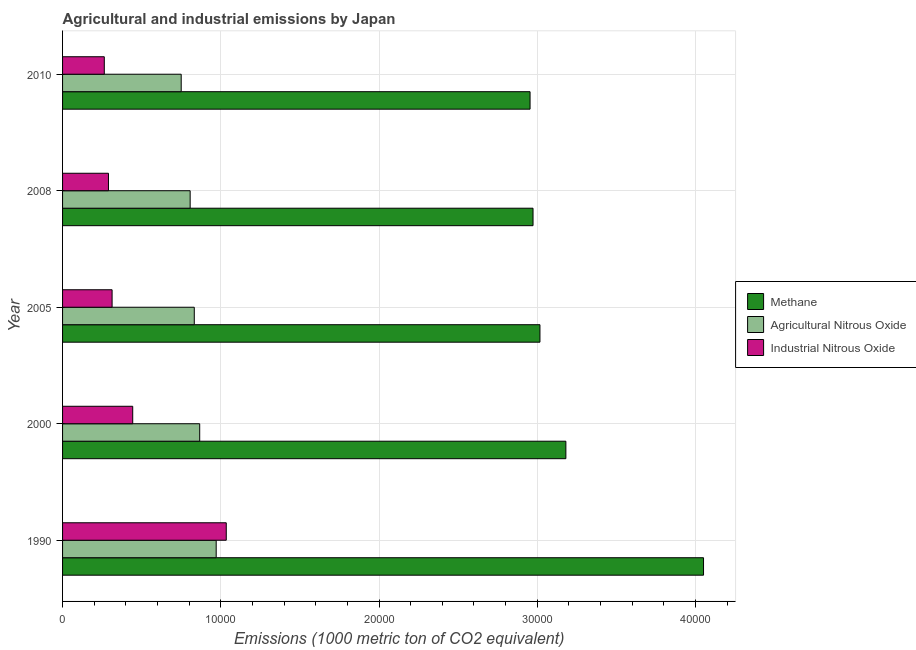Are the number of bars per tick equal to the number of legend labels?
Provide a succinct answer. Yes. How many bars are there on the 2nd tick from the top?
Ensure brevity in your answer.  3. What is the label of the 3rd group of bars from the top?
Your answer should be compact. 2005. What is the amount of industrial nitrous oxide emissions in 2008?
Keep it short and to the point. 2901. Across all years, what is the maximum amount of agricultural nitrous oxide emissions?
Offer a terse response. 9708.8. Across all years, what is the minimum amount of agricultural nitrous oxide emissions?
Provide a succinct answer. 7497.9. In which year was the amount of agricultural nitrous oxide emissions maximum?
Keep it short and to the point. 1990. In which year was the amount of agricultural nitrous oxide emissions minimum?
Offer a very short reply. 2010. What is the total amount of agricultural nitrous oxide emissions in the graph?
Provide a succinct answer. 4.23e+04. What is the difference between the amount of industrial nitrous oxide emissions in 1990 and that in 2010?
Offer a terse response. 7707.7. What is the difference between the amount of methane emissions in 1990 and the amount of agricultural nitrous oxide emissions in 2010?
Ensure brevity in your answer.  3.30e+04. What is the average amount of agricultural nitrous oxide emissions per year?
Make the answer very short. 8452.46. In the year 2000, what is the difference between the amount of methane emissions and amount of agricultural nitrous oxide emissions?
Offer a terse response. 2.31e+04. What is the ratio of the amount of methane emissions in 1990 to that in 2000?
Provide a short and direct response. 1.27. What is the difference between the highest and the second highest amount of agricultural nitrous oxide emissions?
Offer a terse response. 1041.6. What is the difference between the highest and the lowest amount of methane emissions?
Your answer should be compact. 1.10e+04. In how many years, is the amount of methane emissions greater than the average amount of methane emissions taken over all years?
Your answer should be very brief. 1. What does the 3rd bar from the top in 2005 represents?
Your response must be concise. Methane. What does the 1st bar from the bottom in 2000 represents?
Give a very brief answer. Methane. Are all the bars in the graph horizontal?
Make the answer very short. Yes. How many years are there in the graph?
Provide a succinct answer. 5. Are the values on the major ticks of X-axis written in scientific E-notation?
Give a very brief answer. No. Does the graph contain grids?
Provide a short and direct response. Yes. How many legend labels are there?
Give a very brief answer. 3. How are the legend labels stacked?
Offer a very short reply. Vertical. What is the title of the graph?
Ensure brevity in your answer.  Agricultural and industrial emissions by Japan. What is the label or title of the X-axis?
Provide a succinct answer. Emissions (1000 metric ton of CO2 equivalent). What is the Emissions (1000 metric ton of CO2 equivalent) in Methane in 1990?
Keep it short and to the point. 4.05e+04. What is the Emissions (1000 metric ton of CO2 equivalent) of Agricultural Nitrous Oxide in 1990?
Make the answer very short. 9708.8. What is the Emissions (1000 metric ton of CO2 equivalent) in Industrial Nitrous Oxide in 1990?
Your response must be concise. 1.03e+04. What is the Emissions (1000 metric ton of CO2 equivalent) of Methane in 2000?
Provide a succinct answer. 3.18e+04. What is the Emissions (1000 metric ton of CO2 equivalent) in Agricultural Nitrous Oxide in 2000?
Offer a terse response. 8667.2. What is the Emissions (1000 metric ton of CO2 equivalent) of Industrial Nitrous Oxide in 2000?
Your answer should be compact. 4433.9. What is the Emissions (1000 metric ton of CO2 equivalent) in Methane in 2005?
Keep it short and to the point. 3.02e+04. What is the Emissions (1000 metric ton of CO2 equivalent) of Agricultural Nitrous Oxide in 2005?
Make the answer very short. 8324.7. What is the Emissions (1000 metric ton of CO2 equivalent) in Industrial Nitrous Oxide in 2005?
Ensure brevity in your answer.  3130.3. What is the Emissions (1000 metric ton of CO2 equivalent) in Methane in 2008?
Your answer should be compact. 2.97e+04. What is the Emissions (1000 metric ton of CO2 equivalent) of Agricultural Nitrous Oxide in 2008?
Your answer should be very brief. 8063.7. What is the Emissions (1000 metric ton of CO2 equivalent) in Industrial Nitrous Oxide in 2008?
Your response must be concise. 2901. What is the Emissions (1000 metric ton of CO2 equivalent) in Methane in 2010?
Your answer should be very brief. 2.95e+04. What is the Emissions (1000 metric ton of CO2 equivalent) of Agricultural Nitrous Oxide in 2010?
Make the answer very short. 7497.9. What is the Emissions (1000 metric ton of CO2 equivalent) of Industrial Nitrous Oxide in 2010?
Provide a short and direct response. 2637.7. Across all years, what is the maximum Emissions (1000 metric ton of CO2 equivalent) in Methane?
Ensure brevity in your answer.  4.05e+04. Across all years, what is the maximum Emissions (1000 metric ton of CO2 equivalent) of Agricultural Nitrous Oxide?
Your answer should be very brief. 9708.8. Across all years, what is the maximum Emissions (1000 metric ton of CO2 equivalent) in Industrial Nitrous Oxide?
Provide a succinct answer. 1.03e+04. Across all years, what is the minimum Emissions (1000 metric ton of CO2 equivalent) of Methane?
Your answer should be compact. 2.95e+04. Across all years, what is the minimum Emissions (1000 metric ton of CO2 equivalent) in Agricultural Nitrous Oxide?
Offer a terse response. 7497.9. Across all years, what is the minimum Emissions (1000 metric ton of CO2 equivalent) of Industrial Nitrous Oxide?
Provide a succinct answer. 2637.7. What is the total Emissions (1000 metric ton of CO2 equivalent) of Methane in the graph?
Your response must be concise. 1.62e+05. What is the total Emissions (1000 metric ton of CO2 equivalent) in Agricultural Nitrous Oxide in the graph?
Offer a terse response. 4.23e+04. What is the total Emissions (1000 metric ton of CO2 equivalent) of Industrial Nitrous Oxide in the graph?
Keep it short and to the point. 2.34e+04. What is the difference between the Emissions (1000 metric ton of CO2 equivalent) in Methane in 1990 and that in 2000?
Your response must be concise. 8700.7. What is the difference between the Emissions (1000 metric ton of CO2 equivalent) in Agricultural Nitrous Oxide in 1990 and that in 2000?
Provide a succinct answer. 1041.6. What is the difference between the Emissions (1000 metric ton of CO2 equivalent) of Industrial Nitrous Oxide in 1990 and that in 2000?
Your response must be concise. 5911.5. What is the difference between the Emissions (1000 metric ton of CO2 equivalent) of Methane in 1990 and that in 2005?
Give a very brief answer. 1.03e+04. What is the difference between the Emissions (1000 metric ton of CO2 equivalent) of Agricultural Nitrous Oxide in 1990 and that in 2005?
Make the answer very short. 1384.1. What is the difference between the Emissions (1000 metric ton of CO2 equivalent) of Industrial Nitrous Oxide in 1990 and that in 2005?
Your answer should be compact. 7215.1. What is the difference between the Emissions (1000 metric ton of CO2 equivalent) in Methane in 1990 and that in 2008?
Ensure brevity in your answer.  1.08e+04. What is the difference between the Emissions (1000 metric ton of CO2 equivalent) of Agricultural Nitrous Oxide in 1990 and that in 2008?
Your answer should be very brief. 1645.1. What is the difference between the Emissions (1000 metric ton of CO2 equivalent) in Industrial Nitrous Oxide in 1990 and that in 2008?
Ensure brevity in your answer.  7444.4. What is the difference between the Emissions (1000 metric ton of CO2 equivalent) in Methane in 1990 and that in 2010?
Provide a succinct answer. 1.10e+04. What is the difference between the Emissions (1000 metric ton of CO2 equivalent) of Agricultural Nitrous Oxide in 1990 and that in 2010?
Your response must be concise. 2210.9. What is the difference between the Emissions (1000 metric ton of CO2 equivalent) of Industrial Nitrous Oxide in 1990 and that in 2010?
Keep it short and to the point. 7707.7. What is the difference between the Emissions (1000 metric ton of CO2 equivalent) in Methane in 2000 and that in 2005?
Give a very brief answer. 1638. What is the difference between the Emissions (1000 metric ton of CO2 equivalent) in Agricultural Nitrous Oxide in 2000 and that in 2005?
Keep it short and to the point. 342.5. What is the difference between the Emissions (1000 metric ton of CO2 equivalent) of Industrial Nitrous Oxide in 2000 and that in 2005?
Keep it short and to the point. 1303.6. What is the difference between the Emissions (1000 metric ton of CO2 equivalent) in Methane in 2000 and that in 2008?
Keep it short and to the point. 2075.3. What is the difference between the Emissions (1000 metric ton of CO2 equivalent) of Agricultural Nitrous Oxide in 2000 and that in 2008?
Ensure brevity in your answer.  603.5. What is the difference between the Emissions (1000 metric ton of CO2 equivalent) in Industrial Nitrous Oxide in 2000 and that in 2008?
Provide a succinct answer. 1532.9. What is the difference between the Emissions (1000 metric ton of CO2 equivalent) in Methane in 2000 and that in 2010?
Provide a succinct answer. 2263.3. What is the difference between the Emissions (1000 metric ton of CO2 equivalent) in Agricultural Nitrous Oxide in 2000 and that in 2010?
Keep it short and to the point. 1169.3. What is the difference between the Emissions (1000 metric ton of CO2 equivalent) in Industrial Nitrous Oxide in 2000 and that in 2010?
Offer a terse response. 1796.2. What is the difference between the Emissions (1000 metric ton of CO2 equivalent) in Methane in 2005 and that in 2008?
Offer a terse response. 437.3. What is the difference between the Emissions (1000 metric ton of CO2 equivalent) of Agricultural Nitrous Oxide in 2005 and that in 2008?
Ensure brevity in your answer.  261. What is the difference between the Emissions (1000 metric ton of CO2 equivalent) of Industrial Nitrous Oxide in 2005 and that in 2008?
Provide a short and direct response. 229.3. What is the difference between the Emissions (1000 metric ton of CO2 equivalent) in Methane in 2005 and that in 2010?
Provide a succinct answer. 625.3. What is the difference between the Emissions (1000 metric ton of CO2 equivalent) of Agricultural Nitrous Oxide in 2005 and that in 2010?
Keep it short and to the point. 826.8. What is the difference between the Emissions (1000 metric ton of CO2 equivalent) in Industrial Nitrous Oxide in 2005 and that in 2010?
Ensure brevity in your answer.  492.6. What is the difference between the Emissions (1000 metric ton of CO2 equivalent) in Methane in 2008 and that in 2010?
Your response must be concise. 188. What is the difference between the Emissions (1000 metric ton of CO2 equivalent) in Agricultural Nitrous Oxide in 2008 and that in 2010?
Make the answer very short. 565.8. What is the difference between the Emissions (1000 metric ton of CO2 equivalent) of Industrial Nitrous Oxide in 2008 and that in 2010?
Your answer should be compact. 263.3. What is the difference between the Emissions (1000 metric ton of CO2 equivalent) in Methane in 1990 and the Emissions (1000 metric ton of CO2 equivalent) in Agricultural Nitrous Oxide in 2000?
Your answer should be compact. 3.18e+04. What is the difference between the Emissions (1000 metric ton of CO2 equivalent) of Methane in 1990 and the Emissions (1000 metric ton of CO2 equivalent) of Industrial Nitrous Oxide in 2000?
Keep it short and to the point. 3.61e+04. What is the difference between the Emissions (1000 metric ton of CO2 equivalent) of Agricultural Nitrous Oxide in 1990 and the Emissions (1000 metric ton of CO2 equivalent) of Industrial Nitrous Oxide in 2000?
Keep it short and to the point. 5274.9. What is the difference between the Emissions (1000 metric ton of CO2 equivalent) in Methane in 1990 and the Emissions (1000 metric ton of CO2 equivalent) in Agricultural Nitrous Oxide in 2005?
Provide a succinct answer. 3.22e+04. What is the difference between the Emissions (1000 metric ton of CO2 equivalent) of Methane in 1990 and the Emissions (1000 metric ton of CO2 equivalent) of Industrial Nitrous Oxide in 2005?
Keep it short and to the point. 3.74e+04. What is the difference between the Emissions (1000 metric ton of CO2 equivalent) in Agricultural Nitrous Oxide in 1990 and the Emissions (1000 metric ton of CO2 equivalent) in Industrial Nitrous Oxide in 2005?
Make the answer very short. 6578.5. What is the difference between the Emissions (1000 metric ton of CO2 equivalent) in Methane in 1990 and the Emissions (1000 metric ton of CO2 equivalent) in Agricultural Nitrous Oxide in 2008?
Offer a terse response. 3.24e+04. What is the difference between the Emissions (1000 metric ton of CO2 equivalent) of Methane in 1990 and the Emissions (1000 metric ton of CO2 equivalent) of Industrial Nitrous Oxide in 2008?
Give a very brief answer. 3.76e+04. What is the difference between the Emissions (1000 metric ton of CO2 equivalent) in Agricultural Nitrous Oxide in 1990 and the Emissions (1000 metric ton of CO2 equivalent) in Industrial Nitrous Oxide in 2008?
Ensure brevity in your answer.  6807.8. What is the difference between the Emissions (1000 metric ton of CO2 equivalent) in Methane in 1990 and the Emissions (1000 metric ton of CO2 equivalent) in Agricultural Nitrous Oxide in 2010?
Your answer should be compact. 3.30e+04. What is the difference between the Emissions (1000 metric ton of CO2 equivalent) in Methane in 1990 and the Emissions (1000 metric ton of CO2 equivalent) in Industrial Nitrous Oxide in 2010?
Keep it short and to the point. 3.79e+04. What is the difference between the Emissions (1000 metric ton of CO2 equivalent) in Agricultural Nitrous Oxide in 1990 and the Emissions (1000 metric ton of CO2 equivalent) in Industrial Nitrous Oxide in 2010?
Provide a short and direct response. 7071.1. What is the difference between the Emissions (1000 metric ton of CO2 equivalent) of Methane in 2000 and the Emissions (1000 metric ton of CO2 equivalent) of Agricultural Nitrous Oxide in 2005?
Provide a short and direct response. 2.35e+04. What is the difference between the Emissions (1000 metric ton of CO2 equivalent) of Methane in 2000 and the Emissions (1000 metric ton of CO2 equivalent) of Industrial Nitrous Oxide in 2005?
Make the answer very short. 2.87e+04. What is the difference between the Emissions (1000 metric ton of CO2 equivalent) of Agricultural Nitrous Oxide in 2000 and the Emissions (1000 metric ton of CO2 equivalent) of Industrial Nitrous Oxide in 2005?
Make the answer very short. 5536.9. What is the difference between the Emissions (1000 metric ton of CO2 equivalent) in Methane in 2000 and the Emissions (1000 metric ton of CO2 equivalent) in Agricultural Nitrous Oxide in 2008?
Your answer should be compact. 2.37e+04. What is the difference between the Emissions (1000 metric ton of CO2 equivalent) in Methane in 2000 and the Emissions (1000 metric ton of CO2 equivalent) in Industrial Nitrous Oxide in 2008?
Offer a terse response. 2.89e+04. What is the difference between the Emissions (1000 metric ton of CO2 equivalent) in Agricultural Nitrous Oxide in 2000 and the Emissions (1000 metric ton of CO2 equivalent) in Industrial Nitrous Oxide in 2008?
Keep it short and to the point. 5766.2. What is the difference between the Emissions (1000 metric ton of CO2 equivalent) of Methane in 2000 and the Emissions (1000 metric ton of CO2 equivalent) of Agricultural Nitrous Oxide in 2010?
Your response must be concise. 2.43e+04. What is the difference between the Emissions (1000 metric ton of CO2 equivalent) of Methane in 2000 and the Emissions (1000 metric ton of CO2 equivalent) of Industrial Nitrous Oxide in 2010?
Give a very brief answer. 2.92e+04. What is the difference between the Emissions (1000 metric ton of CO2 equivalent) of Agricultural Nitrous Oxide in 2000 and the Emissions (1000 metric ton of CO2 equivalent) of Industrial Nitrous Oxide in 2010?
Offer a very short reply. 6029.5. What is the difference between the Emissions (1000 metric ton of CO2 equivalent) in Methane in 2005 and the Emissions (1000 metric ton of CO2 equivalent) in Agricultural Nitrous Oxide in 2008?
Provide a short and direct response. 2.21e+04. What is the difference between the Emissions (1000 metric ton of CO2 equivalent) in Methane in 2005 and the Emissions (1000 metric ton of CO2 equivalent) in Industrial Nitrous Oxide in 2008?
Your answer should be very brief. 2.73e+04. What is the difference between the Emissions (1000 metric ton of CO2 equivalent) of Agricultural Nitrous Oxide in 2005 and the Emissions (1000 metric ton of CO2 equivalent) of Industrial Nitrous Oxide in 2008?
Keep it short and to the point. 5423.7. What is the difference between the Emissions (1000 metric ton of CO2 equivalent) in Methane in 2005 and the Emissions (1000 metric ton of CO2 equivalent) in Agricultural Nitrous Oxide in 2010?
Give a very brief answer. 2.27e+04. What is the difference between the Emissions (1000 metric ton of CO2 equivalent) in Methane in 2005 and the Emissions (1000 metric ton of CO2 equivalent) in Industrial Nitrous Oxide in 2010?
Make the answer very short. 2.75e+04. What is the difference between the Emissions (1000 metric ton of CO2 equivalent) of Agricultural Nitrous Oxide in 2005 and the Emissions (1000 metric ton of CO2 equivalent) of Industrial Nitrous Oxide in 2010?
Give a very brief answer. 5687. What is the difference between the Emissions (1000 metric ton of CO2 equivalent) of Methane in 2008 and the Emissions (1000 metric ton of CO2 equivalent) of Agricultural Nitrous Oxide in 2010?
Make the answer very short. 2.22e+04. What is the difference between the Emissions (1000 metric ton of CO2 equivalent) in Methane in 2008 and the Emissions (1000 metric ton of CO2 equivalent) in Industrial Nitrous Oxide in 2010?
Your answer should be very brief. 2.71e+04. What is the difference between the Emissions (1000 metric ton of CO2 equivalent) of Agricultural Nitrous Oxide in 2008 and the Emissions (1000 metric ton of CO2 equivalent) of Industrial Nitrous Oxide in 2010?
Offer a very short reply. 5426. What is the average Emissions (1000 metric ton of CO2 equivalent) in Methane per year?
Your answer should be very brief. 3.24e+04. What is the average Emissions (1000 metric ton of CO2 equivalent) of Agricultural Nitrous Oxide per year?
Ensure brevity in your answer.  8452.46. What is the average Emissions (1000 metric ton of CO2 equivalent) in Industrial Nitrous Oxide per year?
Make the answer very short. 4689.66. In the year 1990, what is the difference between the Emissions (1000 metric ton of CO2 equivalent) in Methane and Emissions (1000 metric ton of CO2 equivalent) in Agricultural Nitrous Oxide?
Ensure brevity in your answer.  3.08e+04. In the year 1990, what is the difference between the Emissions (1000 metric ton of CO2 equivalent) in Methane and Emissions (1000 metric ton of CO2 equivalent) in Industrial Nitrous Oxide?
Provide a short and direct response. 3.02e+04. In the year 1990, what is the difference between the Emissions (1000 metric ton of CO2 equivalent) in Agricultural Nitrous Oxide and Emissions (1000 metric ton of CO2 equivalent) in Industrial Nitrous Oxide?
Provide a short and direct response. -636.6. In the year 2000, what is the difference between the Emissions (1000 metric ton of CO2 equivalent) in Methane and Emissions (1000 metric ton of CO2 equivalent) in Agricultural Nitrous Oxide?
Offer a terse response. 2.31e+04. In the year 2000, what is the difference between the Emissions (1000 metric ton of CO2 equivalent) of Methane and Emissions (1000 metric ton of CO2 equivalent) of Industrial Nitrous Oxide?
Your answer should be compact. 2.74e+04. In the year 2000, what is the difference between the Emissions (1000 metric ton of CO2 equivalent) of Agricultural Nitrous Oxide and Emissions (1000 metric ton of CO2 equivalent) of Industrial Nitrous Oxide?
Keep it short and to the point. 4233.3. In the year 2005, what is the difference between the Emissions (1000 metric ton of CO2 equivalent) in Methane and Emissions (1000 metric ton of CO2 equivalent) in Agricultural Nitrous Oxide?
Offer a terse response. 2.18e+04. In the year 2005, what is the difference between the Emissions (1000 metric ton of CO2 equivalent) in Methane and Emissions (1000 metric ton of CO2 equivalent) in Industrial Nitrous Oxide?
Keep it short and to the point. 2.70e+04. In the year 2005, what is the difference between the Emissions (1000 metric ton of CO2 equivalent) of Agricultural Nitrous Oxide and Emissions (1000 metric ton of CO2 equivalent) of Industrial Nitrous Oxide?
Ensure brevity in your answer.  5194.4. In the year 2008, what is the difference between the Emissions (1000 metric ton of CO2 equivalent) in Methane and Emissions (1000 metric ton of CO2 equivalent) in Agricultural Nitrous Oxide?
Keep it short and to the point. 2.17e+04. In the year 2008, what is the difference between the Emissions (1000 metric ton of CO2 equivalent) of Methane and Emissions (1000 metric ton of CO2 equivalent) of Industrial Nitrous Oxide?
Offer a very short reply. 2.68e+04. In the year 2008, what is the difference between the Emissions (1000 metric ton of CO2 equivalent) of Agricultural Nitrous Oxide and Emissions (1000 metric ton of CO2 equivalent) of Industrial Nitrous Oxide?
Offer a very short reply. 5162.7. In the year 2010, what is the difference between the Emissions (1000 metric ton of CO2 equivalent) in Methane and Emissions (1000 metric ton of CO2 equivalent) in Agricultural Nitrous Oxide?
Keep it short and to the point. 2.20e+04. In the year 2010, what is the difference between the Emissions (1000 metric ton of CO2 equivalent) of Methane and Emissions (1000 metric ton of CO2 equivalent) of Industrial Nitrous Oxide?
Provide a short and direct response. 2.69e+04. In the year 2010, what is the difference between the Emissions (1000 metric ton of CO2 equivalent) of Agricultural Nitrous Oxide and Emissions (1000 metric ton of CO2 equivalent) of Industrial Nitrous Oxide?
Your response must be concise. 4860.2. What is the ratio of the Emissions (1000 metric ton of CO2 equivalent) in Methane in 1990 to that in 2000?
Keep it short and to the point. 1.27. What is the ratio of the Emissions (1000 metric ton of CO2 equivalent) of Agricultural Nitrous Oxide in 1990 to that in 2000?
Offer a terse response. 1.12. What is the ratio of the Emissions (1000 metric ton of CO2 equivalent) of Industrial Nitrous Oxide in 1990 to that in 2000?
Make the answer very short. 2.33. What is the ratio of the Emissions (1000 metric ton of CO2 equivalent) of Methane in 1990 to that in 2005?
Ensure brevity in your answer.  1.34. What is the ratio of the Emissions (1000 metric ton of CO2 equivalent) in Agricultural Nitrous Oxide in 1990 to that in 2005?
Provide a succinct answer. 1.17. What is the ratio of the Emissions (1000 metric ton of CO2 equivalent) in Industrial Nitrous Oxide in 1990 to that in 2005?
Offer a terse response. 3.3. What is the ratio of the Emissions (1000 metric ton of CO2 equivalent) in Methane in 1990 to that in 2008?
Your response must be concise. 1.36. What is the ratio of the Emissions (1000 metric ton of CO2 equivalent) in Agricultural Nitrous Oxide in 1990 to that in 2008?
Provide a short and direct response. 1.2. What is the ratio of the Emissions (1000 metric ton of CO2 equivalent) in Industrial Nitrous Oxide in 1990 to that in 2008?
Ensure brevity in your answer.  3.57. What is the ratio of the Emissions (1000 metric ton of CO2 equivalent) of Methane in 1990 to that in 2010?
Keep it short and to the point. 1.37. What is the ratio of the Emissions (1000 metric ton of CO2 equivalent) in Agricultural Nitrous Oxide in 1990 to that in 2010?
Your answer should be very brief. 1.29. What is the ratio of the Emissions (1000 metric ton of CO2 equivalent) in Industrial Nitrous Oxide in 1990 to that in 2010?
Offer a terse response. 3.92. What is the ratio of the Emissions (1000 metric ton of CO2 equivalent) of Methane in 2000 to that in 2005?
Your response must be concise. 1.05. What is the ratio of the Emissions (1000 metric ton of CO2 equivalent) in Agricultural Nitrous Oxide in 2000 to that in 2005?
Keep it short and to the point. 1.04. What is the ratio of the Emissions (1000 metric ton of CO2 equivalent) of Industrial Nitrous Oxide in 2000 to that in 2005?
Your response must be concise. 1.42. What is the ratio of the Emissions (1000 metric ton of CO2 equivalent) of Methane in 2000 to that in 2008?
Provide a succinct answer. 1.07. What is the ratio of the Emissions (1000 metric ton of CO2 equivalent) of Agricultural Nitrous Oxide in 2000 to that in 2008?
Offer a terse response. 1.07. What is the ratio of the Emissions (1000 metric ton of CO2 equivalent) of Industrial Nitrous Oxide in 2000 to that in 2008?
Ensure brevity in your answer.  1.53. What is the ratio of the Emissions (1000 metric ton of CO2 equivalent) in Methane in 2000 to that in 2010?
Provide a succinct answer. 1.08. What is the ratio of the Emissions (1000 metric ton of CO2 equivalent) of Agricultural Nitrous Oxide in 2000 to that in 2010?
Provide a short and direct response. 1.16. What is the ratio of the Emissions (1000 metric ton of CO2 equivalent) of Industrial Nitrous Oxide in 2000 to that in 2010?
Make the answer very short. 1.68. What is the ratio of the Emissions (1000 metric ton of CO2 equivalent) of Methane in 2005 to that in 2008?
Your answer should be compact. 1.01. What is the ratio of the Emissions (1000 metric ton of CO2 equivalent) of Agricultural Nitrous Oxide in 2005 to that in 2008?
Keep it short and to the point. 1.03. What is the ratio of the Emissions (1000 metric ton of CO2 equivalent) of Industrial Nitrous Oxide in 2005 to that in 2008?
Provide a short and direct response. 1.08. What is the ratio of the Emissions (1000 metric ton of CO2 equivalent) in Methane in 2005 to that in 2010?
Give a very brief answer. 1.02. What is the ratio of the Emissions (1000 metric ton of CO2 equivalent) in Agricultural Nitrous Oxide in 2005 to that in 2010?
Make the answer very short. 1.11. What is the ratio of the Emissions (1000 metric ton of CO2 equivalent) of Industrial Nitrous Oxide in 2005 to that in 2010?
Offer a terse response. 1.19. What is the ratio of the Emissions (1000 metric ton of CO2 equivalent) in Methane in 2008 to that in 2010?
Keep it short and to the point. 1.01. What is the ratio of the Emissions (1000 metric ton of CO2 equivalent) of Agricultural Nitrous Oxide in 2008 to that in 2010?
Make the answer very short. 1.08. What is the ratio of the Emissions (1000 metric ton of CO2 equivalent) in Industrial Nitrous Oxide in 2008 to that in 2010?
Your answer should be very brief. 1.1. What is the difference between the highest and the second highest Emissions (1000 metric ton of CO2 equivalent) in Methane?
Ensure brevity in your answer.  8700.7. What is the difference between the highest and the second highest Emissions (1000 metric ton of CO2 equivalent) of Agricultural Nitrous Oxide?
Your answer should be compact. 1041.6. What is the difference between the highest and the second highest Emissions (1000 metric ton of CO2 equivalent) of Industrial Nitrous Oxide?
Your answer should be compact. 5911.5. What is the difference between the highest and the lowest Emissions (1000 metric ton of CO2 equivalent) of Methane?
Your answer should be compact. 1.10e+04. What is the difference between the highest and the lowest Emissions (1000 metric ton of CO2 equivalent) in Agricultural Nitrous Oxide?
Keep it short and to the point. 2210.9. What is the difference between the highest and the lowest Emissions (1000 metric ton of CO2 equivalent) in Industrial Nitrous Oxide?
Your answer should be compact. 7707.7. 